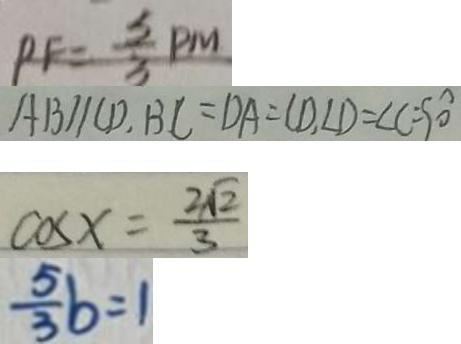Convert formula to latex. <formula><loc_0><loc_0><loc_500><loc_500>P F = \frac { 3 } { 3 } P M 
 A B / / C D . B C = D A = C D , \angle D = \angle C = 9 0 ^ { \circ } 
 \cos x = \frac { 2 \sqrt { 2 } } { 3 } 
 \frac { 5 } { 3 } b = 1</formula> 